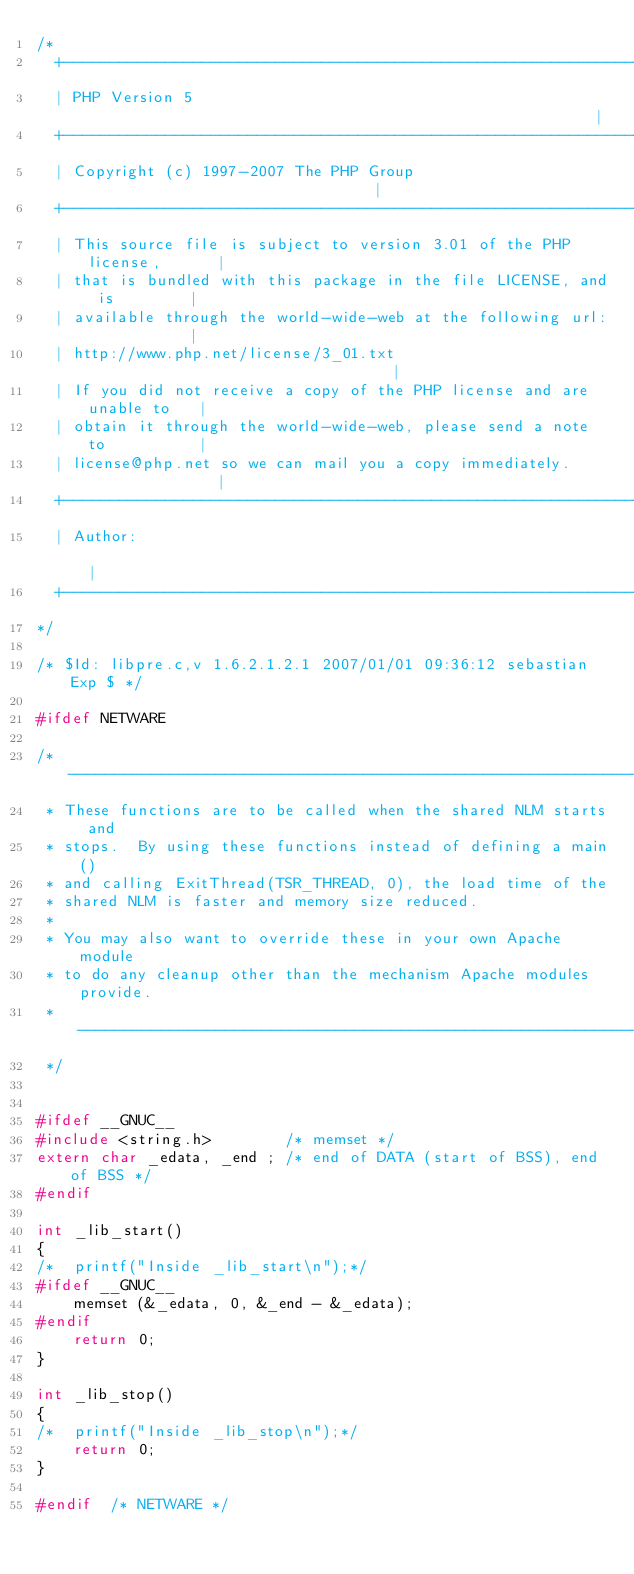<code> <loc_0><loc_0><loc_500><loc_500><_C_>/*
  +----------------------------------------------------------------------+
  | PHP Version 5                                                        |
  +----------------------------------------------------------------------+
  | Copyright (c) 1997-2007 The PHP Group                                |
  +----------------------------------------------------------------------+
  | This source file is subject to version 3.01 of the PHP license,      |
  | that is bundled with this package in the file LICENSE, and is        |
  | available through the world-wide-web at the following url:           |
  | http://www.php.net/license/3_01.txt                                  |
  | If you did not receive a copy of the PHP license and are unable to   |
  | obtain it through the world-wide-web, please send a note to          |
  | license@php.net so we can mail you a copy immediately.               |
  +----------------------------------------------------------------------+
  | Author:                                                              |
  +----------------------------------------------------------------------+
*/

/* $Id: libpre.c,v 1.6.2.1.2.1 2007/01/01 09:36:12 sebastian Exp $ */

#ifdef NETWARE

/* ------------------------------------------------------------------
 * These functions are to be called when the shared NLM starts and
 * stops.  By using these functions instead of defining a main()
 * and calling ExitThread(TSR_THREAD, 0), the load time of the
 * shared NLM is faster and memory size reduced.
 * 
 * You may also want to override these in your own Apache module
 * to do any cleanup other than the mechanism Apache modules provide.
 * ------------------------------------------------------------------
 */


#ifdef __GNUC__
#include <string.h>        /* memset */
extern char _edata, _end ; /* end of DATA (start of BSS), end of BSS */
#endif

int _lib_start()
{
/*	printf("Inside _lib_start\n");*/
#ifdef __GNUC__
    memset (&_edata, 0, &_end - &_edata);
#endif
    return 0;
}

int _lib_stop()
{
/*	printf("Inside _lib_stop\n");*/
    return 0;
}

#endif	/* NETWARE */
</code> 